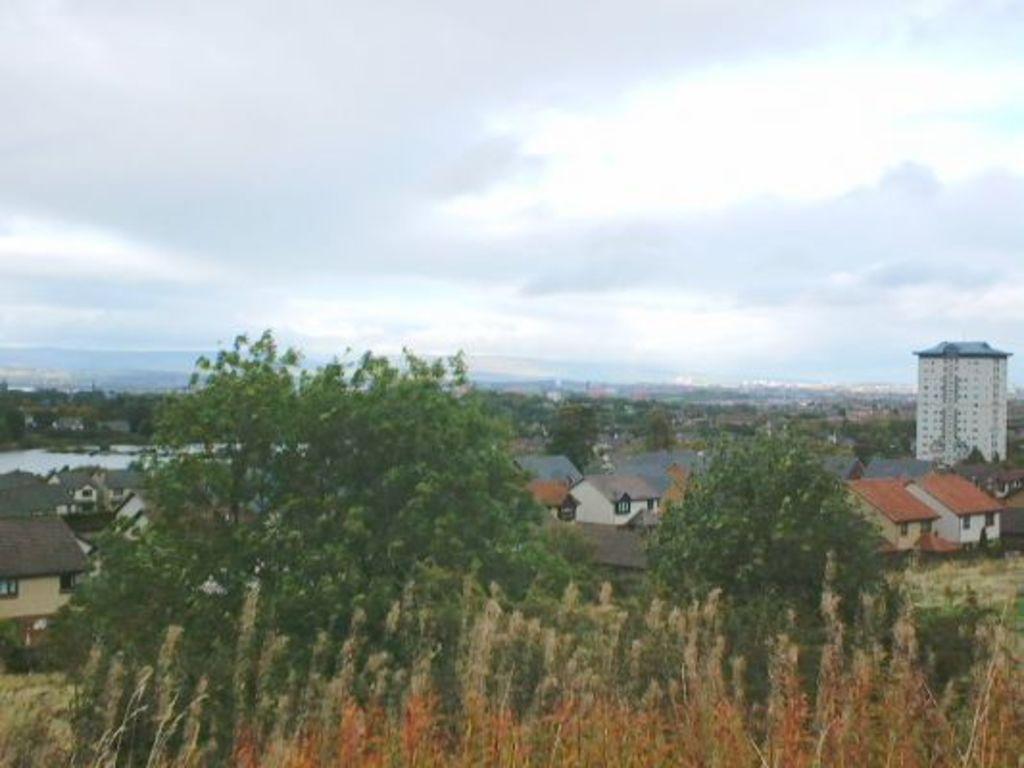In one or two sentences, can you explain what this image depicts? In this image I can see few trees and bushes in the front. In the background I can see number of buildings, number of trees, clouds and the sky. 